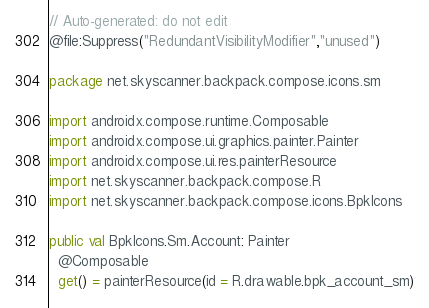Convert code to text. <code><loc_0><loc_0><loc_500><loc_500><_Kotlin_>// Auto-generated: do not edit
@file:Suppress("RedundantVisibilityModifier","unused")

package net.skyscanner.backpack.compose.icons.sm

import androidx.compose.runtime.Composable
import androidx.compose.ui.graphics.painter.Painter
import androidx.compose.ui.res.painterResource
import net.skyscanner.backpack.compose.R
import net.skyscanner.backpack.compose.icons.BpkIcons

public val BpkIcons.Sm.Account: Painter
  @Composable
  get() = painterResource(id = R.drawable.bpk_account_sm)
</code> 